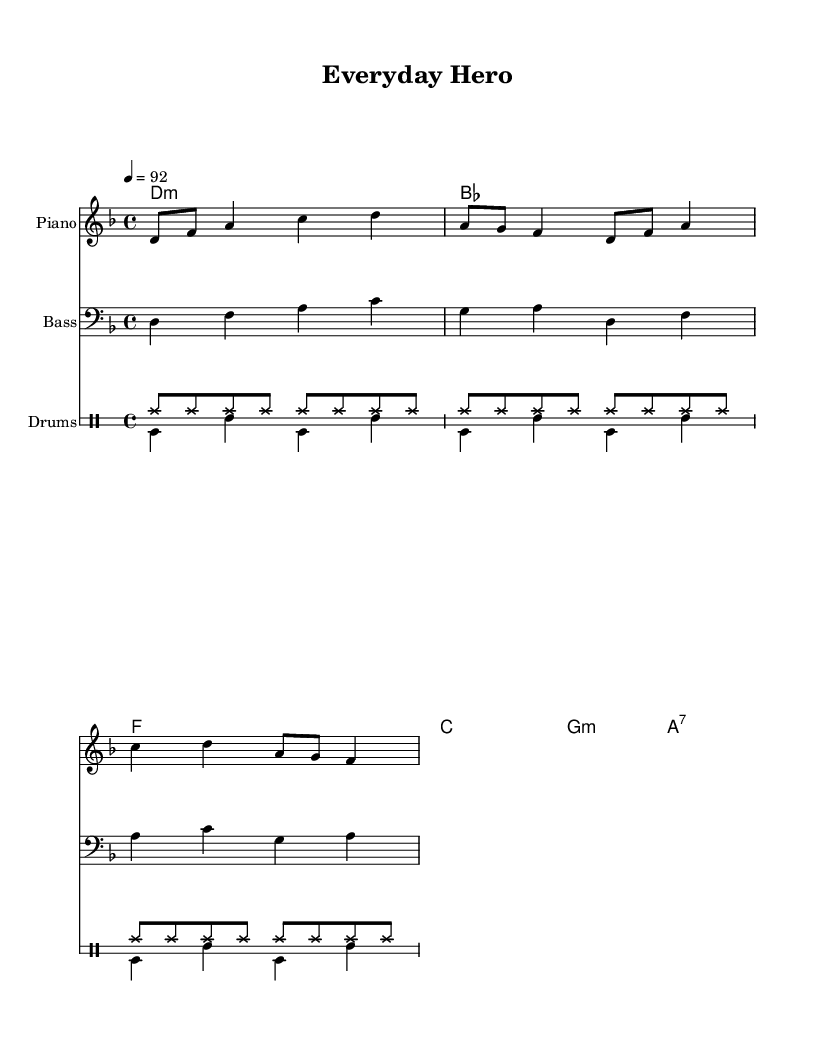what is the key signature of this music? The key signature is indicated by the presence of two flats, which are B flat and E flat. This signifies that the piece is in D minor.
Answer: D minor what is the time signature of this piece? The time signature is located at the beginning of the sheet music, showing a four over four, which is common in many music genres including hip hop.
Answer: 4/4 what is the tempo marking given in this sheet music? The tempo marking is found indicated as a quarter note equals 92 beats per minute, which suggests the speed at which the piece should be played.
Answer: 92 how many measures does the melody section contain? Counting the measures in the melody section, there are five distinct sets of rhythms which indicate five measures in total.
Answer: 5 what musical form is predominantly used in hip hop reflected in this piece? The structure of the music follows a repetitive pattern with distinct verses and possible hooks, both commonly found in hip hop for storytelling.
Answer: Verse-chorus what does the bass line primarily support in this hip hop piece? The bass line in the piece underlines the harmonic structure and creates a groove, which is essential in hip hop to keep the rhythm and drive the narrative.
Answer: Harmonic structure what is the significance of the drum patterns in hip hop music as shown here? The drum patterns include both hi-hat and bass drum rhythms that provide a backbone and are integral to the hip hop genre, setting the rhythmic foundation for storytelling.
Answer: Rhythmic foundation 